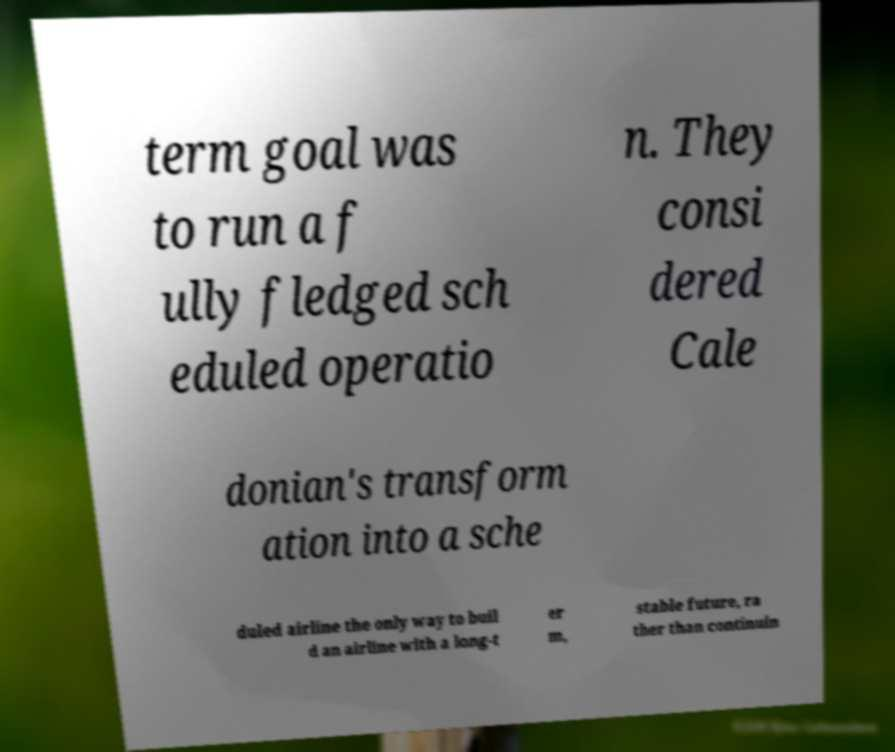Can you read and provide the text displayed in the image?This photo seems to have some interesting text. Can you extract and type it out for me? term goal was to run a f ully fledged sch eduled operatio n. They consi dered Cale donian's transform ation into a sche duled airline the only way to buil d an airline with a long-t er m, stable future, ra ther than continuin 